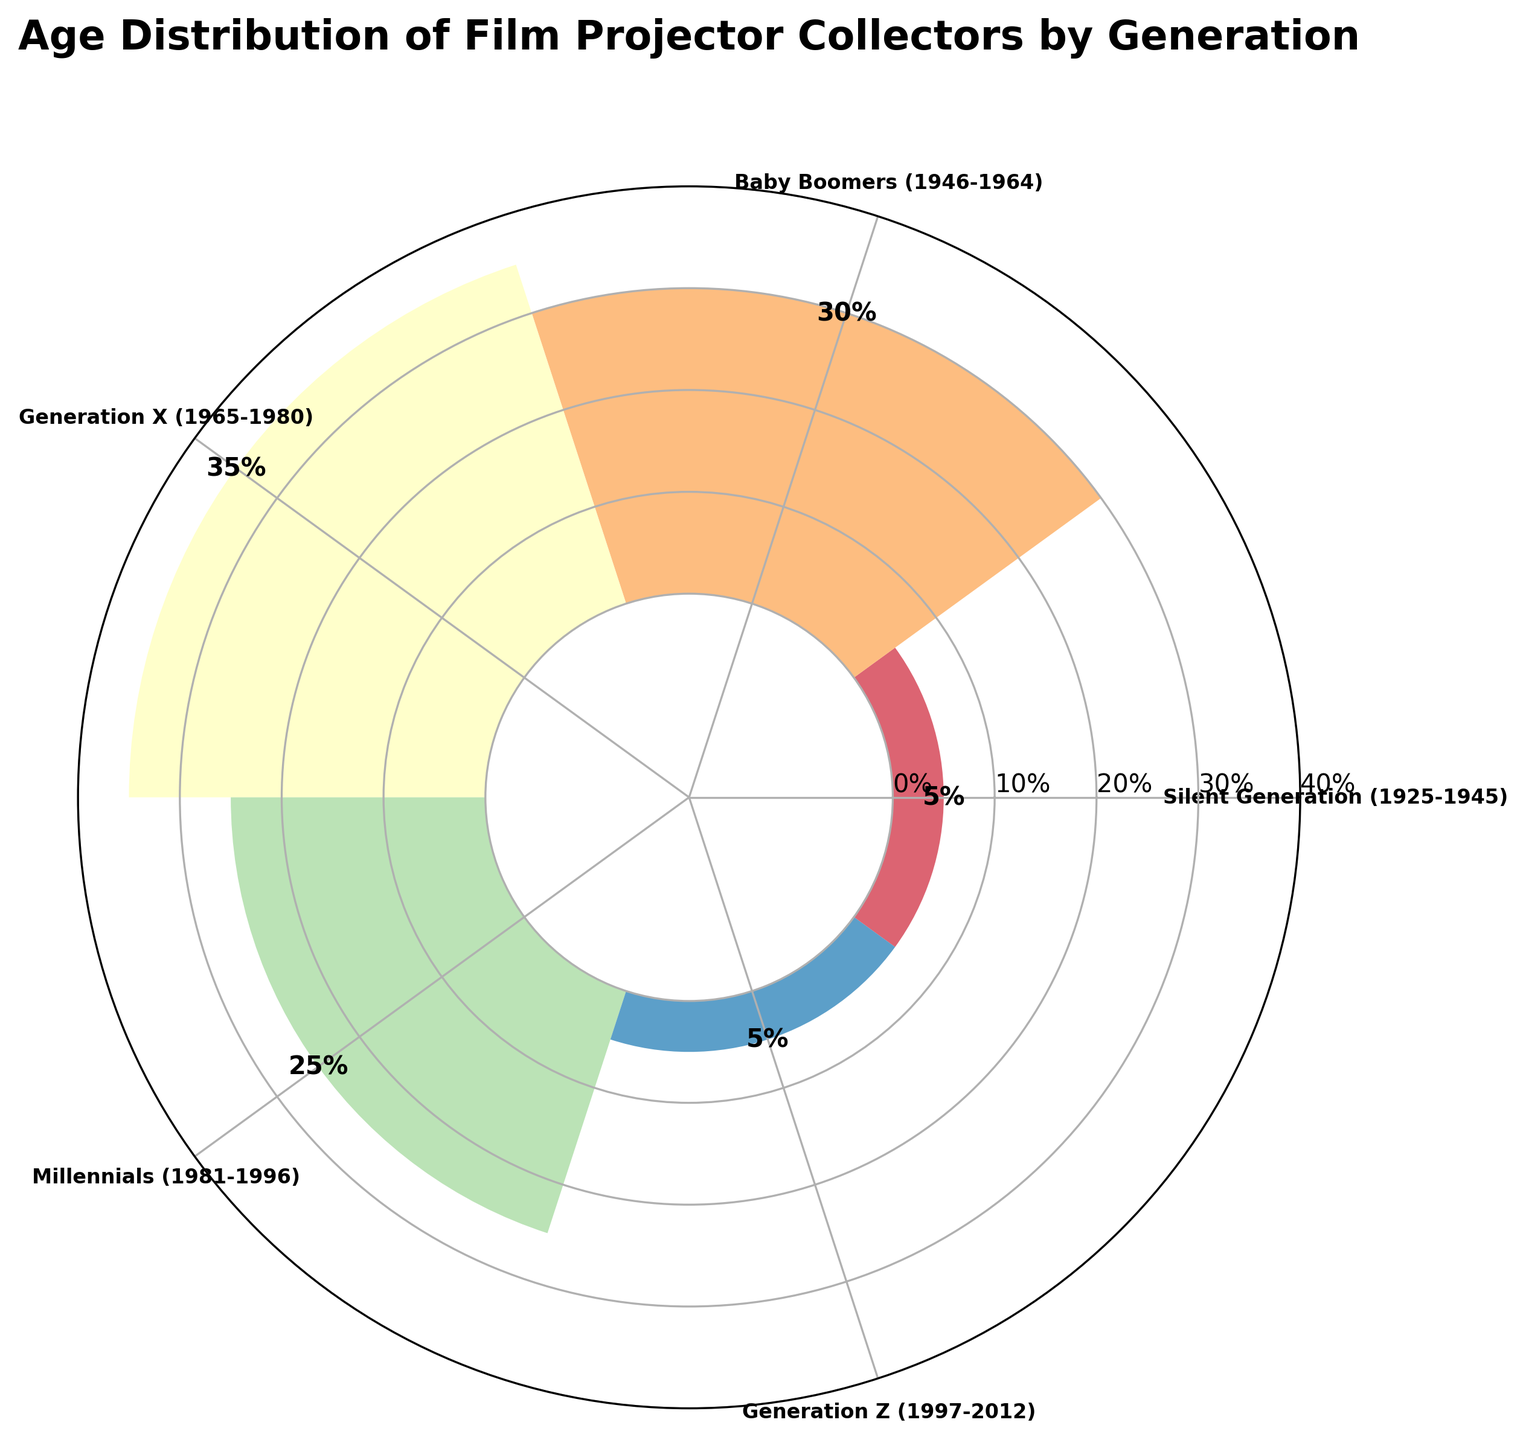Which generation has the highest percentage of film projector collectors? The longest bar on the polar chart has the label "Generation X (1965-1980)" and the value on top of it is 35%, indicating that Generation X has the highest percentage of collectors.
Answer: Generation X What is the percentage of film projector collectors from the Silent Generation? The bar labeled "Silent Generation (1925-1945)" has a value on top of it indicating the percentage. The value is 5%.
Answer: 5% What is the combined percentage of film projector collectors from Millennials and Generation Z? The bar labeled "Millennials (1981-1996)" shows a percentage of 25%, and the bar labeled "Generation Z (1997-2012)" shows a percentage of 5%. Adding these two values together gives 25% + 5% = 30%.
Answer: 30% Which generation has a percentage of collectors equal to 5%? Both the bars labeled "Silent Generation (1925-1945)" and "Generation Z (1997-2012)" have values of 5% on top of them.
Answer: Silent Generation and Generation Z How does the percentage of Baby Boomers compare to that of Millennials? The bar labeled "Baby Boomers (1946-1964)" has a percentage of 30%, and the bar labeled "Millennials (1981-1996)" has a percentage of 25%, so Baby Boomers have a higher percentage by 5%.
Answer: Higher by 5% What is the difference in the percentage of collectors between the oldest and youngest generations represented? The "Silent Generation (1925-1945)" and "Generation Z (1997-2012)" both have percentages of 5%, so the difference is 5% - 5% = 0%.
Answer: 0% What is the average percentage of collectors across all generations? The percentages are [5%, 30%, 35%, 25%, 5%]. Summing these values gives 5 + 30 + 35 + 25 + 5 = 100%. There are 5 generations, so the average is 100 / 5 = 20%.
Answer: 20% How many generations have a percentage of collectors that is greater than 20%? The bars with values greater than 20% are "Baby Boomers (30%)", "Generation X (35%)", and "Millennials (25%)". So, there are 3 such generations.
Answer: 3 